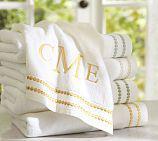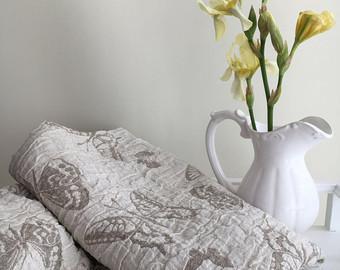The first image is the image on the left, the second image is the image on the right. For the images displayed, is the sentence "The outside can be seen in the image on the left." factually correct? Answer yes or no. Yes. The first image is the image on the left, the second image is the image on the right. For the images shown, is this caption "A porcelain pitcher is shown by something made of fabric in one image." true? Answer yes or no. Yes. 